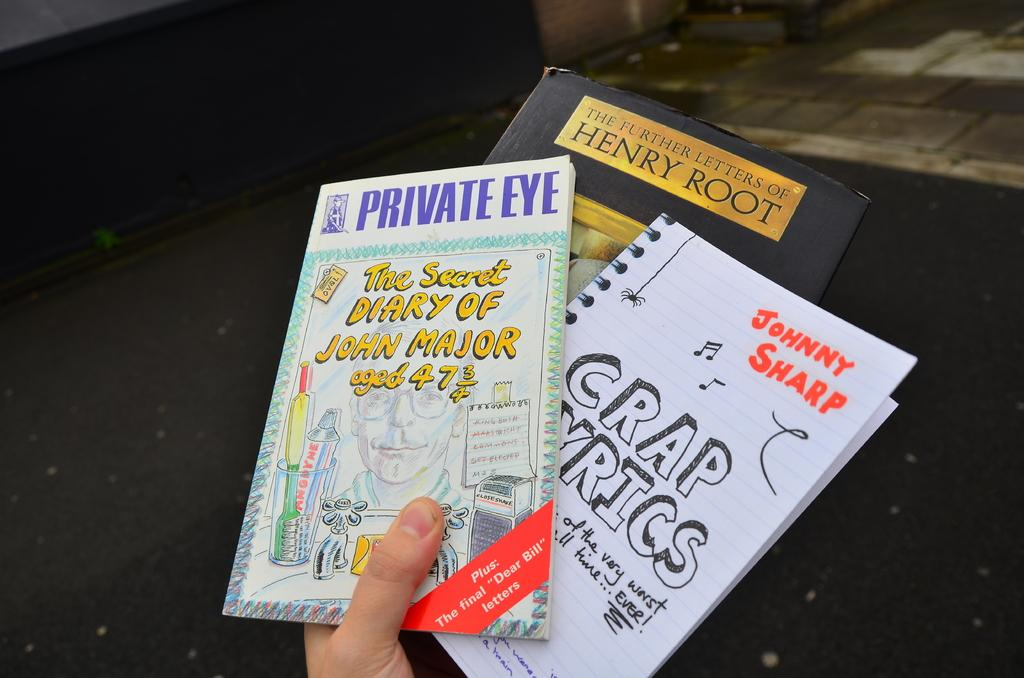<image>
Present a compact description of the photo's key features. Three books including crap lyrics, private eye the secret diary of John Major aged 47 3/4, and the Further Letters of Henry Root. 